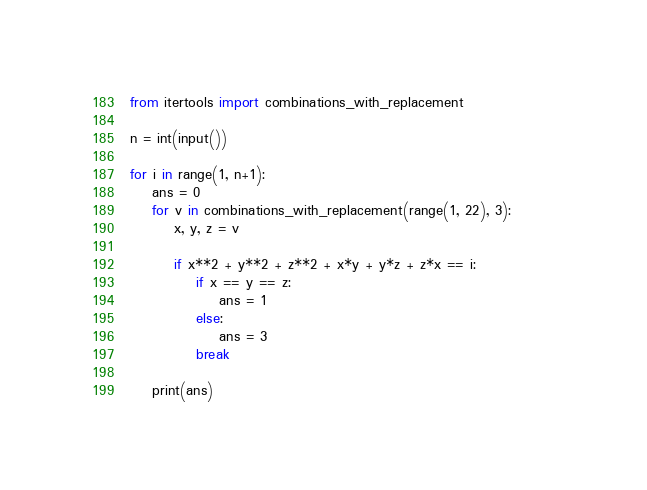<code> <loc_0><loc_0><loc_500><loc_500><_Python_>from itertools import combinations_with_replacement

n = int(input())

for i in range(1, n+1):
    ans = 0
    for v in combinations_with_replacement(range(1, 22), 3):        
        x, y, z = v

        if x**2 + y**2 + z**2 + x*y + y*z + z*x == i:
            if x == y == z:
                ans = 1
            else:
                ans = 3
            break

    print(ans)</code> 